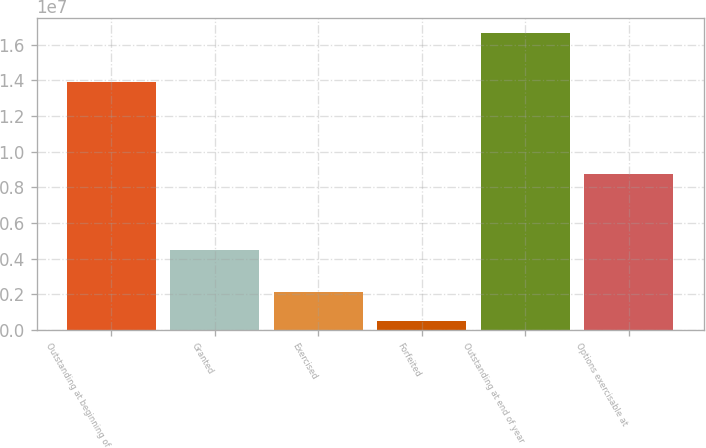Convert chart. <chart><loc_0><loc_0><loc_500><loc_500><bar_chart><fcel>Outstanding at beginning of<fcel>Granted<fcel>Exercised<fcel>Forfeited<fcel>Outstanding at end of year<fcel>Options exercisable at<nl><fcel>1.38891e+07<fcel>4.46849e+06<fcel>2.10776e+06<fcel>489550<fcel>1.66716e+07<fcel>8.7522e+06<nl></chart> 